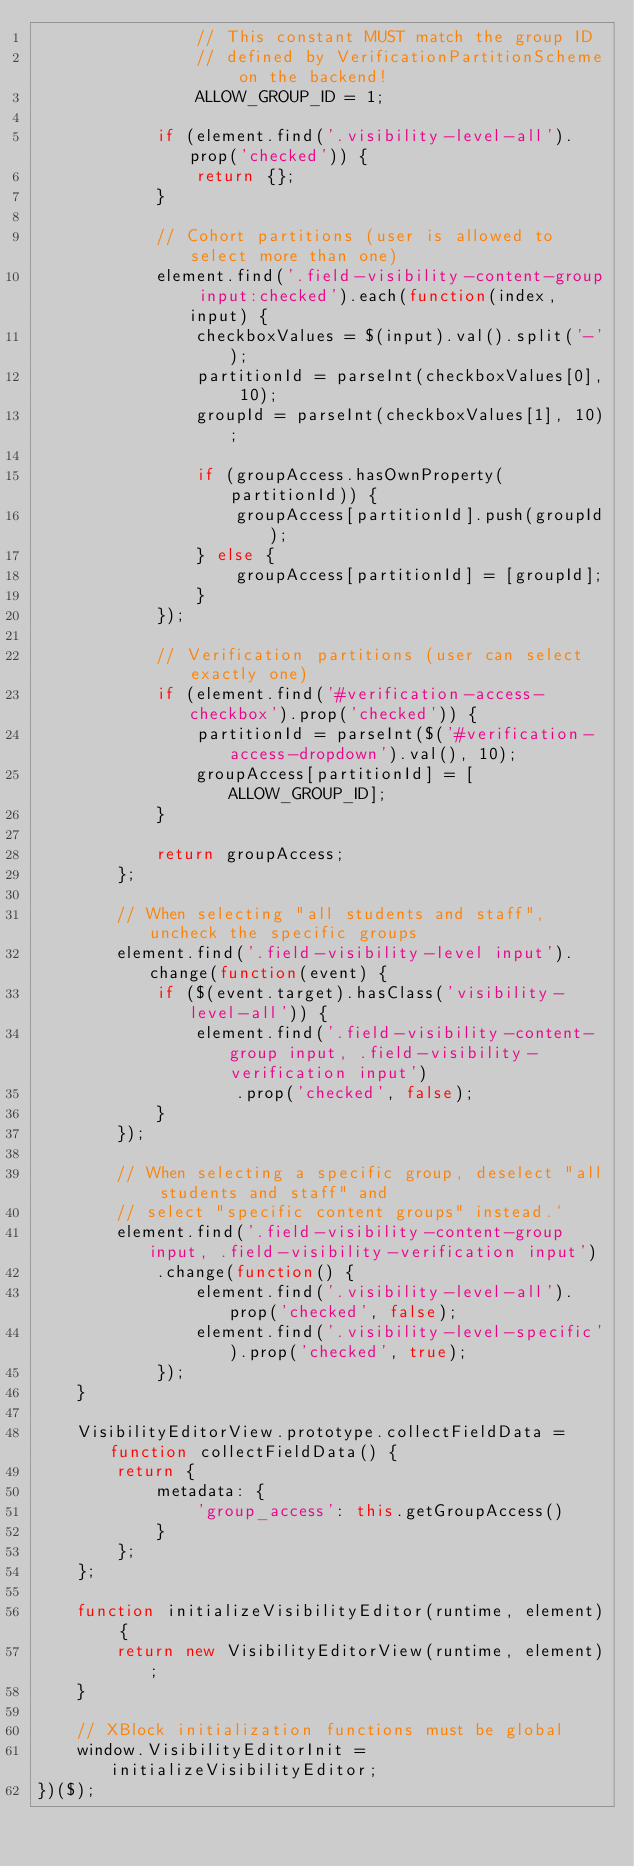<code> <loc_0><loc_0><loc_500><loc_500><_JavaScript_>                // This constant MUST match the group ID
                // defined by VerificationPartitionScheme on the backend!
                ALLOW_GROUP_ID = 1;

            if (element.find('.visibility-level-all').prop('checked')) {
                return {};
            }

            // Cohort partitions (user is allowed to select more than one)
            element.find('.field-visibility-content-group input:checked').each(function(index, input) {
                checkboxValues = $(input).val().split('-');
                partitionId = parseInt(checkboxValues[0], 10);
                groupId = parseInt(checkboxValues[1], 10);

                if (groupAccess.hasOwnProperty(partitionId)) {
                    groupAccess[partitionId].push(groupId);
                } else {
                    groupAccess[partitionId] = [groupId];
                }
            });

            // Verification partitions (user can select exactly one)
            if (element.find('#verification-access-checkbox').prop('checked')) {
                partitionId = parseInt($('#verification-access-dropdown').val(), 10);
                groupAccess[partitionId] = [ALLOW_GROUP_ID];
            }

            return groupAccess;
        };

        // When selecting "all students and staff", uncheck the specific groups
        element.find('.field-visibility-level input').change(function(event) {
            if ($(event.target).hasClass('visibility-level-all')) {
                element.find('.field-visibility-content-group input, .field-visibility-verification input')
                    .prop('checked', false);
            }
        });

        // When selecting a specific group, deselect "all students and staff" and
        // select "specific content groups" instead.`
        element.find('.field-visibility-content-group input, .field-visibility-verification input')
            .change(function() {
                element.find('.visibility-level-all').prop('checked', false);
                element.find('.visibility-level-specific').prop('checked', true);
            });
    }

    VisibilityEditorView.prototype.collectFieldData = function collectFieldData() {
        return {
            metadata: {
                'group_access': this.getGroupAccess()
            }
        };
    };

    function initializeVisibilityEditor(runtime, element) {
        return new VisibilityEditorView(runtime, element);
    }

    // XBlock initialization functions must be global
    window.VisibilityEditorInit = initializeVisibilityEditor;
})($);
</code> 